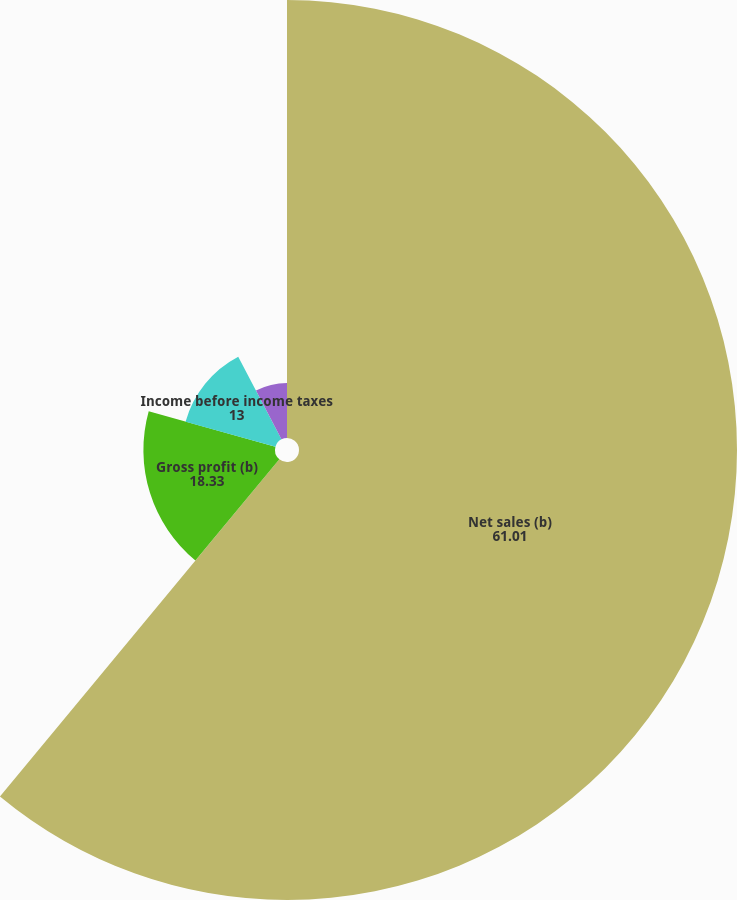Convert chart to OTSL. <chart><loc_0><loc_0><loc_500><loc_500><pie_chart><fcel>Net sales (b)<fcel>Gross profit (b)<fcel>Income before income taxes<fcel>Net income<nl><fcel>61.01%<fcel>18.33%<fcel>13.0%<fcel>7.66%<nl></chart> 